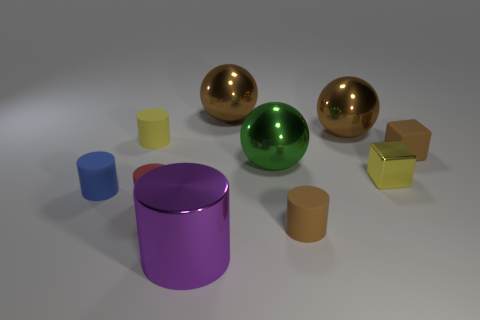Is the number of red cylinders that are on the left side of the red rubber thing the same as the number of objects?
Offer a terse response. No. There is a brown matte thing on the right side of the tiny yellow thing that is right of the red cylinder; what number of big purple objects are on the left side of it?
Ensure brevity in your answer.  1. The tiny rubber cylinder that is behind the big green shiny object is what color?
Your answer should be compact. Yellow. There is a brown object that is on the right side of the green ball and behind the tiny yellow cylinder; what is its material?
Ensure brevity in your answer.  Metal. There is a small yellow thing left of the purple metal cylinder; what number of large things are in front of it?
Your response must be concise. 2. The small yellow shiny thing is what shape?
Your response must be concise. Cube. There is a small yellow object that is the same material as the big green sphere; what shape is it?
Provide a succinct answer. Cube. There is a small yellow object that is behind the small metal object; is it the same shape as the small shiny object?
Keep it short and to the point. No. There is a big shiny thing that is in front of the large green thing; what shape is it?
Give a very brief answer. Cylinder. There is another small object that is the same color as the small shiny thing; what is its shape?
Keep it short and to the point. Cylinder. 